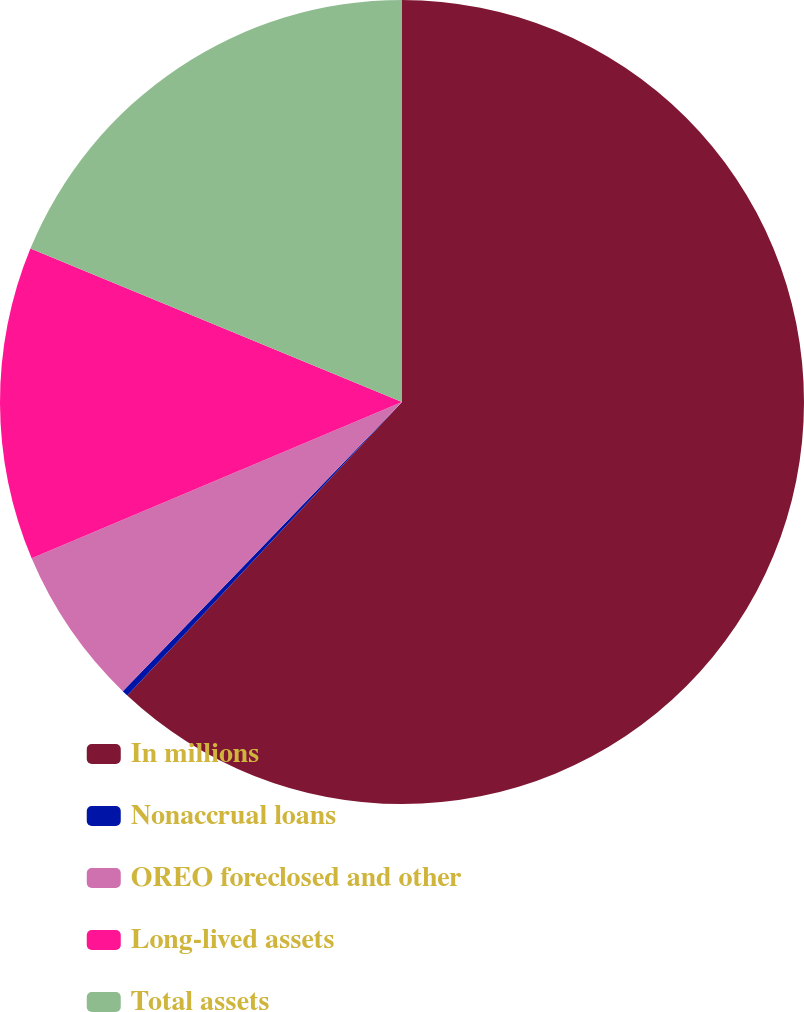<chart> <loc_0><loc_0><loc_500><loc_500><pie_chart><fcel>In millions<fcel>Nonaccrual loans<fcel>OREO foreclosed and other<fcel>Long-lived assets<fcel>Total assets<nl><fcel>61.98%<fcel>0.25%<fcel>6.42%<fcel>12.59%<fcel>18.77%<nl></chart> 